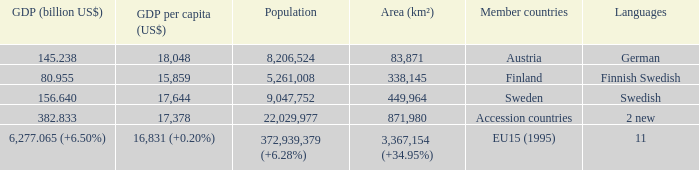Name the area for german 83871.0. 